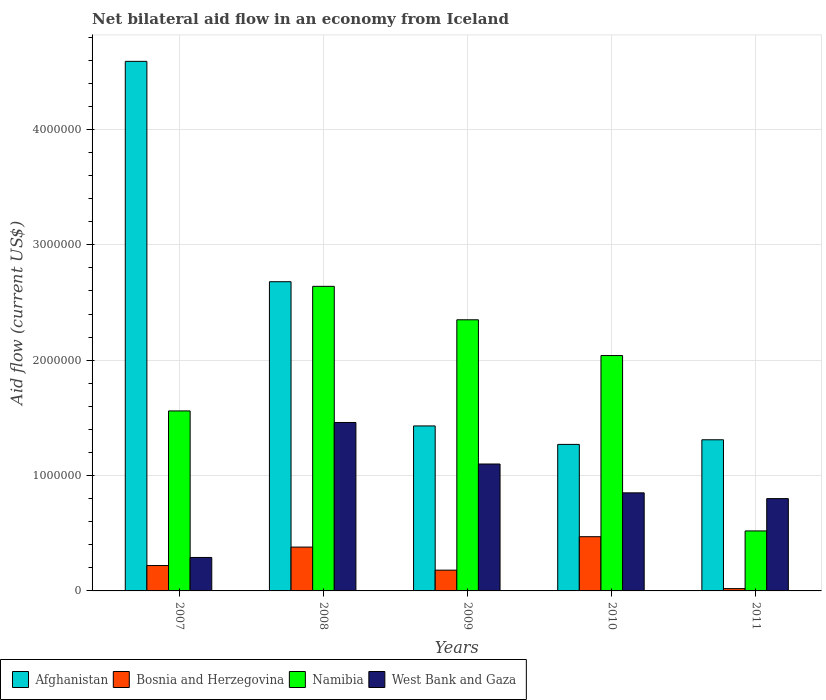Are the number of bars per tick equal to the number of legend labels?
Your answer should be very brief. Yes. What is the net bilateral aid flow in Namibia in 2010?
Provide a short and direct response. 2.04e+06. Across all years, what is the maximum net bilateral aid flow in Namibia?
Keep it short and to the point. 2.64e+06. In which year was the net bilateral aid flow in Namibia minimum?
Make the answer very short. 2011. What is the total net bilateral aid flow in Afghanistan in the graph?
Your answer should be very brief. 1.13e+07. What is the difference between the net bilateral aid flow in Afghanistan in 2007 and the net bilateral aid flow in Bosnia and Herzegovina in 2010?
Provide a succinct answer. 4.12e+06. What is the average net bilateral aid flow in Bosnia and Herzegovina per year?
Provide a short and direct response. 2.54e+05. In the year 2008, what is the difference between the net bilateral aid flow in West Bank and Gaza and net bilateral aid flow in Bosnia and Herzegovina?
Ensure brevity in your answer.  1.08e+06. In how many years, is the net bilateral aid flow in Bosnia and Herzegovina greater than 4600000 US$?
Offer a very short reply. 0. What is the ratio of the net bilateral aid flow in Namibia in 2007 to that in 2011?
Offer a very short reply. 3. What is the difference between the highest and the lowest net bilateral aid flow in Afghanistan?
Offer a terse response. 3.32e+06. Is the sum of the net bilateral aid flow in Bosnia and Herzegovina in 2008 and 2009 greater than the maximum net bilateral aid flow in Afghanistan across all years?
Make the answer very short. No. What does the 2nd bar from the left in 2010 represents?
Your response must be concise. Bosnia and Herzegovina. What does the 2nd bar from the right in 2008 represents?
Give a very brief answer. Namibia. Are all the bars in the graph horizontal?
Your answer should be compact. No. Are the values on the major ticks of Y-axis written in scientific E-notation?
Provide a short and direct response. No. Does the graph contain any zero values?
Give a very brief answer. No. Does the graph contain grids?
Ensure brevity in your answer.  Yes. How many legend labels are there?
Keep it short and to the point. 4. What is the title of the graph?
Provide a succinct answer. Net bilateral aid flow in an economy from Iceland. Does "Colombia" appear as one of the legend labels in the graph?
Offer a terse response. No. What is the label or title of the X-axis?
Keep it short and to the point. Years. What is the Aid flow (current US$) in Afghanistan in 2007?
Keep it short and to the point. 4.59e+06. What is the Aid flow (current US$) of Namibia in 2007?
Offer a terse response. 1.56e+06. What is the Aid flow (current US$) in Afghanistan in 2008?
Offer a very short reply. 2.68e+06. What is the Aid flow (current US$) of Bosnia and Herzegovina in 2008?
Offer a very short reply. 3.80e+05. What is the Aid flow (current US$) in Namibia in 2008?
Offer a very short reply. 2.64e+06. What is the Aid flow (current US$) of West Bank and Gaza in 2008?
Make the answer very short. 1.46e+06. What is the Aid flow (current US$) of Afghanistan in 2009?
Provide a short and direct response. 1.43e+06. What is the Aid flow (current US$) in Namibia in 2009?
Ensure brevity in your answer.  2.35e+06. What is the Aid flow (current US$) of West Bank and Gaza in 2009?
Your answer should be very brief. 1.10e+06. What is the Aid flow (current US$) in Afghanistan in 2010?
Provide a succinct answer. 1.27e+06. What is the Aid flow (current US$) of Bosnia and Herzegovina in 2010?
Your response must be concise. 4.70e+05. What is the Aid flow (current US$) of Namibia in 2010?
Your answer should be very brief. 2.04e+06. What is the Aid flow (current US$) in West Bank and Gaza in 2010?
Give a very brief answer. 8.50e+05. What is the Aid flow (current US$) in Afghanistan in 2011?
Offer a very short reply. 1.31e+06. What is the Aid flow (current US$) of Bosnia and Herzegovina in 2011?
Your answer should be compact. 2.00e+04. What is the Aid flow (current US$) of Namibia in 2011?
Make the answer very short. 5.20e+05. Across all years, what is the maximum Aid flow (current US$) in Afghanistan?
Your answer should be very brief. 4.59e+06. Across all years, what is the maximum Aid flow (current US$) in Namibia?
Make the answer very short. 2.64e+06. Across all years, what is the maximum Aid flow (current US$) in West Bank and Gaza?
Offer a very short reply. 1.46e+06. Across all years, what is the minimum Aid flow (current US$) of Afghanistan?
Give a very brief answer. 1.27e+06. Across all years, what is the minimum Aid flow (current US$) of Namibia?
Offer a very short reply. 5.20e+05. Across all years, what is the minimum Aid flow (current US$) in West Bank and Gaza?
Keep it short and to the point. 2.90e+05. What is the total Aid flow (current US$) in Afghanistan in the graph?
Give a very brief answer. 1.13e+07. What is the total Aid flow (current US$) of Bosnia and Herzegovina in the graph?
Ensure brevity in your answer.  1.27e+06. What is the total Aid flow (current US$) of Namibia in the graph?
Give a very brief answer. 9.11e+06. What is the total Aid flow (current US$) of West Bank and Gaza in the graph?
Offer a very short reply. 4.50e+06. What is the difference between the Aid flow (current US$) in Afghanistan in 2007 and that in 2008?
Offer a very short reply. 1.91e+06. What is the difference between the Aid flow (current US$) of Bosnia and Herzegovina in 2007 and that in 2008?
Your answer should be very brief. -1.60e+05. What is the difference between the Aid flow (current US$) of Namibia in 2007 and that in 2008?
Your answer should be compact. -1.08e+06. What is the difference between the Aid flow (current US$) in West Bank and Gaza in 2007 and that in 2008?
Your answer should be compact. -1.17e+06. What is the difference between the Aid flow (current US$) of Afghanistan in 2007 and that in 2009?
Give a very brief answer. 3.16e+06. What is the difference between the Aid flow (current US$) in Namibia in 2007 and that in 2009?
Ensure brevity in your answer.  -7.90e+05. What is the difference between the Aid flow (current US$) in West Bank and Gaza in 2007 and that in 2009?
Your answer should be compact. -8.10e+05. What is the difference between the Aid flow (current US$) of Afghanistan in 2007 and that in 2010?
Your response must be concise. 3.32e+06. What is the difference between the Aid flow (current US$) in Bosnia and Herzegovina in 2007 and that in 2010?
Provide a succinct answer. -2.50e+05. What is the difference between the Aid flow (current US$) in Namibia in 2007 and that in 2010?
Offer a very short reply. -4.80e+05. What is the difference between the Aid flow (current US$) of West Bank and Gaza in 2007 and that in 2010?
Offer a very short reply. -5.60e+05. What is the difference between the Aid flow (current US$) of Afghanistan in 2007 and that in 2011?
Your answer should be compact. 3.28e+06. What is the difference between the Aid flow (current US$) of Namibia in 2007 and that in 2011?
Provide a short and direct response. 1.04e+06. What is the difference between the Aid flow (current US$) of West Bank and Gaza in 2007 and that in 2011?
Keep it short and to the point. -5.10e+05. What is the difference between the Aid flow (current US$) in Afghanistan in 2008 and that in 2009?
Your answer should be very brief. 1.25e+06. What is the difference between the Aid flow (current US$) of Namibia in 2008 and that in 2009?
Make the answer very short. 2.90e+05. What is the difference between the Aid flow (current US$) of West Bank and Gaza in 2008 and that in 2009?
Your answer should be compact. 3.60e+05. What is the difference between the Aid flow (current US$) in Afghanistan in 2008 and that in 2010?
Your response must be concise. 1.41e+06. What is the difference between the Aid flow (current US$) of Bosnia and Herzegovina in 2008 and that in 2010?
Your answer should be very brief. -9.00e+04. What is the difference between the Aid flow (current US$) in Namibia in 2008 and that in 2010?
Provide a succinct answer. 6.00e+05. What is the difference between the Aid flow (current US$) in Afghanistan in 2008 and that in 2011?
Offer a very short reply. 1.37e+06. What is the difference between the Aid flow (current US$) of Bosnia and Herzegovina in 2008 and that in 2011?
Your response must be concise. 3.60e+05. What is the difference between the Aid flow (current US$) of Namibia in 2008 and that in 2011?
Keep it short and to the point. 2.12e+06. What is the difference between the Aid flow (current US$) of West Bank and Gaza in 2008 and that in 2011?
Your answer should be very brief. 6.60e+05. What is the difference between the Aid flow (current US$) in Afghanistan in 2009 and that in 2010?
Offer a very short reply. 1.60e+05. What is the difference between the Aid flow (current US$) in Namibia in 2009 and that in 2010?
Make the answer very short. 3.10e+05. What is the difference between the Aid flow (current US$) in Namibia in 2009 and that in 2011?
Your response must be concise. 1.83e+06. What is the difference between the Aid flow (current US$) of Afghanistan in 2010 and that in 2011?
Keep it short and to the point. -4.00e+04. What is the difference between the Aid flow (current US$) of Namibia in 2010 and that in 2011?
Your response must be concise. 1.52e+06. What is the difference between the Aid flow (current US$) of West Bank and Gaza in 2010 and that in 2011?
Offer a very short reply. 5.00e+04. What is the difference between the Aid flow (current US$) in Afghanistan in 2007 and the Aid flow (current US$) in Bosnia and Herzegovina in 2008?
Provide a short and direct response. 4.21e+06. What is the difference between the Aid flow (current US$) in Afghanistan in 2007 and the Aid flow (current US$) in Namibia in 2008?
Ensure brevity in your answer.  1.95e+06. What is the difference between the Aid flow (current US$) in Afghanistan in 2007 and the Aid flow (current US$) in West Bank and Gaza in 2008?
Provide a succinct answer. 3.13e+06. What is the difference between the Aid flow (current US$) of Bosnia and Herzegovina in 2007 and the Aid flow (current US$) of Namibia in 2008?
Your response must be concise. -2.42e+06. What is the difference between the Aid flow (current US$) of Bosnia and Herzegovina in 2007 and the Aid flow (current US$) of West Bank and Gaza in 2008?
Give a very brief answer. -1.24e+06. What is the difference between the Aid flow (current US$) in Afghanistan in 2007 and the Aid flow (current US$) in Bosnia and Herzegovina in 2009?
Your answer should be compact. 4.41e+06. What is the difference between the Aid flow (current US$) of Afghanistan in 2007 and the Aid flow (current US$) of Namibia in 2009?
Provide a short and direct response. 2.24e+06. What is the difference between the Aid flow (current US$) in Afghanistan in 2007 and the Aid flow (current US$) in West Bank and Gaza in 2009?
Provide a short and direct response. 3.49e+06. What is the difference between the Aid flow (current US$) in Bosnia and Herzegovina in 2007 and the Aid flow (current US$) in Namibia in 2009?
Your answer should be compact. -2.13e+06. What is the difference between the Aid flow (current US$) of Bosnia and Herzegovina in 2007 and the Aid flow (current US$) of West Bank and Gaza in 2009?
Keep it short and to the point. -8.80e+05. What is the difference between the Aid flow (current US$) in Namibia in 2007 and the Aid flow (current US$) in West Bank and Gaza in 2009?
Keep it short and to the point. 4.60e+05. What is the difference between the Aid flow (current US$) of Afghanistan in 2007 and the Aid flow (current US$) of Bosnia and Herzegovina in 2010?
Ensure brevity in your answer.  4.12e+06. What is the difference between the Aid flow (current US$) of Afghanistan in 2007 and the Aid flow (current US$) of Namibia in 2010?
Offer a very short reply. 2.55e+06. What is the difference between the Aid flow (current US$) of Afghanistan in 2007 and the Aid flow (current US$) of West Bank and Gaza in 2010?
Provide a succinct answer. 3.74e+06. What is the difference between the Aid flow (current US$) in Bosnia and Herzegovina in 2007 and the Aid flow (current US$) in Namibia in 2010?
Give a very brief answer. -1.82e+06. What is the difference between the Aid flow (current US$) of Bosnia and Herzegovina in 2007 and the Aid flow (current US$) of West Bank and Gaza in 2010?
Offer a very short reply. -6.30e+05. What is the difference between the Aid flow (current US$) of Namibia in 2007 and the Aid flow (current US$) of West Bank and Gaza in 2010?
Offer a terse response. 7.10e+05. What is the difference between the Aid flow (current US$) of Afghanistan in 2007 and the Aid flow (current US$) of Bosnia and Herzegovina in 2011?
Provide a short and direct response. 4.57e+06. What is the difference between the Aid flow (current US$) in Afghanistan in 2007 and the Aid flow (current US$) in Namibia in 2011?
Ensure brevity in your answer.  4.07e+06. What is the difference between the Aid flow (current US$) in Afghanistan in 2007 and the Aid flow (current US$) in West Bank and Gaza in 2011?
Your answer should be compact. 3.79e+06. What is the difference between the Aid flow (current US$) in Bosnia and Herzegovina in 2007 and the Aid flow (current US$) in Namibia in 2011?
Your response must be concise. -3.00e+05. What is the difference between the Aid flow (current US$) of Bosnia and Herzegovina in 2007 and the Aid flow (current US$) of West Bank and Gaza in 2011?
Your response must be concise. -5.80e+05. What is the difference between the Aid flow (current US$) in Namibia in 2007 and the Aid flow (current US$) in West Bank and Gaza in 2011?
Your answer should be very brief. 7.60e+05. What is the difference between the Aid flow (current US$) in Afghanistan in 2008 and the Aid flow (current US$) in Bosnia and Herzegovina in 2009?
Your response must be concise. 2.50e+06. What is the difference between the Aid flow (current US$) in Afghanistan in 2008 and the Aid flow (current US$) in Namibia in 2009?
Offer a terse response. 3.30e+05. What is the difference between the Aid flow (current US$) in Afghanistan in 2008 and the Aid flow (current US$) in West Bank and Gaza in 2009?
Give a very brief answer. 1.58e+06. What is the difference between the Aid flow (current US$) of Bosnia and Herzegovina in 2008 and the Aid flow (current US$) of Namibia in 2009?
Offer a terse response. -1.97e+06. What is the difference between the Aid flow (current US$) of Bosnia and Herzegovina in 2008 and the Aid flow (current US$) of West Bank and Gaza in 2009?
Make the answer very short. -7.20e+05. What is the difference between the Aid flow (current US$) of Namibia in 2008 and the Aid flow (current US$) of West Bank and Gaza in 2009?
Make the answer very short. 1.54e+06. What is the difference between the Aid flow (current US$) of Afghanistan in 2008 and the Aid flow (current US$) of Bosnia and Herzegovina in 2010?
Provide a short and direct response. 2.21e+06. What is the difference between the Aid flow (current US$) in Afghanistan in 2008 and the Aid flow (current US$) in Namibia in 2010?
Your response must be concise. 6.40e+05. What is the difference between the Aid flow (current US$) in Afghanistan in 2008 and the Aid flow (current US$) in West Bank and Gaza in 2010?
Your answer should be compact. 1.83e+06. What is the difference between the Aid flow (current US$) in Bosnia and Herzegovina in 2008 and the Aid flow (current US$) in Namibia in 2010?
Your answer should be compact. -1.66e+06. What is the difference between the Aid flow (current US$) in Bosnia and Herzegovina in 2008 and the Aid flow (current US$) in West Bank and Gaza in 2010?
Your answer should be compact. -4.70e+05. What is the difference between the Aid flow (current US$) in Namibia in 2008 and the Aid flow (current US$) in West Bank and Gaza in 2010?
Your response must be concise. 1.79e+06. What is the difference between the Aid flow (current US$) of Afghanistan in 2008 and the Aid flow (current US$) of Bosnia and Herzegovina in 2011?
Provide a short and direct response. 2.66e+06. What is the difference between the Aid flow (current US$) in Afghanistan in 2008 and the Aid flow (current US$) in Namibia in 2011?
Provide a succinct answer. 2.16e+06. What is the difference between the Aid flow (current US$) of Afghanistan in 2008 and the Aid flow (current US$) of West Bank and Gaza in 2011?
Keep it short and to the point. 1.88e+06. What is the difference between the Aid flow (current US$) in Bosnia and Herzegovina in 2008 and the Aid flow (current US$) in West Bank and Gaza in 2011?
Your answer should be very brief. -4.20e+05. What is the difference between the Aid flow (current US$) of Namibia in 2008 and the Aid flow (current US$) of West Bank and Gaza in 2011?
Your answer should be compact. 1.84e+06. What is the difference between the Aid flow (current US$) in Afghanistan in 2009 and the Aid flow (current US$) in Bosnia and Herzegovina in 2010?
Offer a very short reply. 9.60e+05. What is the difference between the Aid flow (current US$) in Afghanistan in 2009 and the Aid flow (current US$) in Namibia in 2010?
Provide a succinct answer. -6.10e+05. What is the difference between the Aid flow (current US$) in Afghanistan in 2009 and the Aid flow (current US$) in West Bank and Gaza in 2010?
Make the answer very short. 5.80e+05. What is the difference between the Aid flow (current US$) of Bosnia and Herzegovina in 2009 and the Aid flow (current US$) of Namibia in 2010?
Your response must be concise. -1.86e+06. What is the difference between the Aid flow (current US$) of Bosnia and Herzegovina in 2009 and the Aid flow (current US$) of West Bank and Gaza in 2010?
Your response must be concise. -6.70e+05. What is the difference between the Aid flow (current US$) of Namibia in 2009 and the Aid flow (current US$) of West Bank and Gaza in 2010?
Your answer should be very brief. 1.50e+06. What is the difference between the Aid flow (current US$) of Afghanistan in 2009 and the Aid flow (current US$) of Bosnia and Herzegovina in 2011?
Give a very brief answer. 1.41e+06. What is the difference between the Aid flow (current US$) of Afghanistan in 2009 and the Aid flow (current US$) of Namibia in 2011?
Your answer should be very brief. 9.10e+05. What is the difference between the Aid flow (current US$) of Afghanistan in 2009 and the Aid flow (current US$) of West Bank and Gaza in 2011?
Ensure brevity in your answer.  6.30e+05. What is the difference between the Aid flow (current US$) of Bosnia and Herzegovina in 2009 and the Aid flow (current US$) of West Bank and Gaza in 2011?
Give a very brief answer. -6.20e+05. What is the difference between the Aid flow (current US$) of Namibia in 2009 and the Aid flow (current US$) of West Bank and Gaza in 2011?
Offer a very short reply. 1.55e+06. What is the difference between the Aid flow (current US$) of Afghanistan in 2010 and the Aid flow (current US$) of Bosnia and Herzegovina in 2011?
Offer a very short reply. 1.25e+06. What is the difference between the Aid flow (current US$) in Afghanistan in 2010 and the Aid flow (current US$) in Namibia in 2011?
Offer a very short reply. 7.50e+05. What is the difference between the Aid flow (current US$) in Bosnia and Herzegovina in 2010 and the Aid flow (current US$) in Namibia in 2011?
Offer a terse response. -5.00e+04. What is the difference between the Aid flow (current US$) of Bosnia and Herzegovina in 2010 and the Aid flow (current US$) of West Bank and Gaza in 2011?
Provide a succinct answer. -3.30e+05. What is the difference between the Aid flow (current US$) in Namibia in 2010 and the Aid flow (current US$) in West Bank and Gaza in 2011?
Provide a short and direct response. 1.24e+06. What is the average Aid flow (current US$) of Afghanistan per year?
Your answer should be compact. 2.26e+06. What is the average Aid flow (current US$) in Bosnia and Herzegovina per year?
Give a very brief answer. 2.54e+05. What is the average Aid flow (current US$) in Namibia per year?
Provide a short and direct response. 1.82e+06. What is the average Aid flow (current US$) of West Bank and Gaza per year?
Make the answer very short. 9.00e+05. In the year 2007, what is the difference between the Aid flow (current US$) in Afghanistan and Aid flow (current US$) in Bosnia and Herzegovina?
Make the answer very short. 4.37e+06. In the year 2007, what is the difference between the Aid flow (current US$) of Afghanistan and Aid flow (current US$) of Namibia?
Your answer should be compact. 3.03e+06. In the year 2007, what is the difference between the Aid flow (current US$) in Afghanistan and Aid flow (current US$) in West Bank and Gaza?
Make the answer very short. 4.30e+06. In the year 2007, what is the difference between the Aid flow (current US$) of Bosnia and Herzegovina and Aid flow (current US$) of Namibia?
Make the answer very short. -1.34e+06. In the year 2007, what is the difference between the Aid flow (current US$) in Bosnia and Herzegovina and Aid flow (current US$) in West Bank and Gaza?
Give a very brief answer. -7.00e+04. In the year 2007, what is the difference between the Aid flow (current US$) in Namibia and Aid flow (current US$) in West Bank and Gaza?
Ensure brevity in your answer.  1.27e+06. In the year 2008, what is the difference between the Aid flow (current US$) in Afghanistan and Aid flow (current US$) in Bosnia and Herzegovina?
Make the answer very short. 2.30e+06. In the year 2008, what is the difference between the Aid flow (current US$) of Afghanistan and Aid flow (current US$) of West Bank and Gaza?
Offer a very short reply. 1.22e+06. In the year 2008, what is the difference between the Aid flow (current US$) in Bosnia and Herzegovina and Aid flow (current US$) in Namibia?
Your response must be concise. -2.26e+06. In the year 2008, what is the difference between the Aid flow (current US$) in Bosnia and Herzegovina and Aid flow (current US$) in West Bank and Gaza?
Provide a short and direct response. -1.08e+06. In the year 2008, what is the difference between the Aid flow (current US$) of Namibia and Aid flow (current US$) of West Bank and Gaza?
Offer a terse response. 1.18e+06. In the year 2009, what is the difference between the Aid flow (current US$) of Afghanistan and Aid flow (current US$) of Bosnia and Herzegovina?
Your answer should be very brief. 1.25e+06. In the year 2009, what is the difference between the Aid flow (current US$) in Afghanistan and Aid flow (current US$) in Namibia?
Make the answer very short. -9.20e+05. In the year 2009, what is the difference between the Aid flow (current US$) of Afghanistan and Aid flow (current US$) of West Bank and Gaza?
Make the answer very short. 3.30e+05. In the year 2009, what is the difference between the Aid flow (current US$) of Bosnia and Herzegovina and Aid flow (current US$) of Namibia?
Your answer should be compact. -2.17e+06. In the year 2009, what is the difference between the Aid flow (current US$) of Bosnia and Herzegovina and Aid flow (current US$) of West Bank and Gaza?
Your answer should be compact. -9.20e+05. In the year 2009, what is the difference between the Aid flow (current US$) of Namibia and Aid flow (current US$) of West Bank and Gaza?
Your response must be concise. 1.25e+06. In the year 2010, what is the difference between the Aid flow (current US$) of Afghanistan and Aid flow (current US$) of Bosnia and Herzegovina?
Provide a succinct answer. 8.00e+05. In the year 2010, what is the difference between the Aid flow (current US$) in Afghanistan and Aid flow (current US$) in Namibia?
Give a very brief answer. -7.70e+05. In the year 2010, what is the difference between the Aid flow (current US$) in Bosnia and Herzegovina and Aid flow (current US$) in Namibia?
Offer a very short reply. -1.57e+06. In the year 2010, what is the difference between the Aid flow (current US$) of Bosnia and Herzegovina and Aid flow (current US$) of West Bank and Gaza?
Give a very brief answer. -3.80e+05. In the year 2010, what is the difference between the Aid flow (current US$) of Namibia and Aid flow (current US$) of West Bank and Gaza?
Provide a succinct answer. 1.19e+06. In the year 2011, what is the difference between the Aid flow (current US$) of Afghanistan and Aid flow (current US$) of Bosnia and Herzegovina?
Your response must be concise. 1.29e+06. In the year 2011, what is the difference between the Aid flow (current US$) of Afghanistan and Aid flow (current US$) of Namibia?
Offer a terse response. 7.90e+05. In the year 2011, what is the difference between the Aid flow (current US$) of Afghanistan and Aid flow (current US$) of West Bank and Gaza?
Provide a short and direct response. 5.10e+05. In the year 2011, what is the difference between the Aid flow (current US$) of Bosnia and Herzegovina and Aid flow (current US$) of Namibia?
Your answer should be very brief. -5.00e+05. In the year 2011, what is the difference between the Aid flow (current US$) of Bosnia and Herzegovina and Aid flow (current US$) of West Bank and Gaza?
Your answer should be very brief. -7.80e+05. In the year 2011, what is the difference between the Aid flow (current US$) of Namibia and Aid flow (current US$) of West Bank and Gaza?
Offer a terse response. -2.80e+05. What is the ratio of the Aid flow (current US$) in Afghanistan in 2007 to that in 2008?
Make the answer very short. 1.71. What is the ratio of the Aid flow (current US$) in Bosnia and Herzegovina in 2007 to that in 2008?
Offer a very short reply. 0.58. What is the ratio of the Aid flow (current US$) in Namibia in 2007 to that in 2008?
Provide a succinct answer. 0.59. What is the ratio of the Aid flow (current US$) in West Bank and Gaza in 2007 to that in 2008?
Provide a short and direct response. 0.2. What is the ratio of the Aid flow (current US$) in Afghanistan in 2007 to that in 2009?
Offer a terse response. 3.21. What is the ratio of the Aid flow (current US$) of Bosnia and Herzegovina in 2007 to that in 2009?
Make the answer very short. 1.22. What is the ratio of the Aid flow (current US$) of Namibia in 2007 to that in 2009?
Offer a very short reply. 0.66. What is the ratio of the Aid flow (current US$) of West Bank and Gaza in 2007 to that in 2009?
Ensure brevity in your answer.  0.26. What is the ratio of the Aid flow (current US$) in Afghanistan in 2007 to that in 2010?
Keep it short and to the point. 3.61. What is the ratio of the Aid flow (current US$) of Bosnia and Herzegovina in 2007 to that in 2010?
Make the answer very short. 0.47. What is the ratio of the Aid flow (current US$) in Namibia in 2007 to that in 2010?
Ensure brevity in your answer.  0.76. What is the ratio of the Aid flow (current US$) of West Bank and Gaza in 2007 to that in 2010?
Offer a very short reply. 0.34. What is the ratio of the Aid flow (current US$) of Afghanistan in 2007 to that in 2011?
Make the answer very short. 3.5. What is the ratio of the Aid flow (current US$) in Namibia in 2007 to that in 2011?
Your response must be concise. 3. What is the ratio of the Aid flow (current US$) of West Bank and Gaza in 2007 to that in 2011?
Provide a short and direct response. 0.36. What is the ratio of the Aid flow (current US$) of Afghanistan in 2008 to that in 2009?
Keep it short and to the point. 1.87. What is the ratio of the Aid flow (current US$) of Bosnia and Herzegovina in 2008 to that in 2009?
Ensure brevity in your answer.  2.11. What is the ratio of the Aid flow (current US$) in Namibia in 2008 to that in 2009?
Provide a short and direct response. 1.12. What is the ratio of the Aid flow (current US$) in West Bank and Gaza in 2008 to that in 2009?
Your answer should be compact. 1.33. What is the ratio of the Aid flow (current US$) of Afghanistan in 2008 to that in 2010?
Offer a terse response. 2.11. What is the ratio of the Aid flow (current US$) in Bosnia and Herzegovina in 2008 to that in 2010?
Ensure brevity in your answer.  0.81. What is the ratio of the Aid flow (current US$) in Namibia in 2008 to that in 2010?
Your response must be concise. 1.29. What is the ratio of the Aid flow (current US$) in West Bank and Gaza in 2008 to that in 2010?
Your answer should be compact. 1.72. What is the ratio of the Aid flow (current US$) in Afghanistan in 2008 to that in 2011?
Give a very brief answer. 2.05. What is the ratio of the Aid flow (current US$) in Bosnia and Herzegovina in 2008 to that in 2011?
Give a very brief answer. 19. What is the ratio of the Aid flow (current US$) in Namibia in 2008 to that in 2011?
Provide a short and direct response. 5.08. What is the ratio of the Aid flow (current US$) in West Bank and Gaza in 2008 to that in 2011?
Give a very brief answer. 1.82. What is the ratio of the Aid flow (current US$) in Afghanistan in 2009 to that in 2010?
Keep it short and to the point. 1.13. What is the ratio of the Aid flow (current US$) of Bosnia and Herzegovina in 2009 to that in 2010?
Your answer should be very brief. 0.38. What is the ratio of the Aid flow (current US$) in Namibia in 2009 to that in 2010?
Keep it short and to the point. 1.15. What is the ratio of the Aid flow (current US$) in West Bank and Gaza in 2009 to that in 2010?
Offer a terse response. 1.29. What is the ratio of the Aid flow (current US$) in Afghanistan in 2009 to that in 2011?
Your response must be concise. 1.09. What is the ratio of the Aid flow (current US$) in Bosnia and Herzegovina in 2009 to that in 2011?
Your answer should be very brief. 9. What is the ratio of the Aid flow (current US$) of Namibia in 2009 to that in 2011?
Offer a terse response. 4.52. What is the ratio of the Aid flow (current US$) in West Bank and Gaza in 2009 to that in 2011?
Offer a very short reply. 1.38. What is the ratio of the Aid flow (current US$) in Afghanistan in 2010 to that in 2011?
Make the answer very short. 0.97. What is the ratio of the Aid flow (current US$) in Namibia in 2010 to that in 2011?
Give a very brief answer. 3.92. What is the ratio of the Aid flow (current US$) in West Bank and Gaza in 2010 to that in 2011?
Offer a terse response. 1.06. What is the difference between the highest and the second highest Aid flow (current US$) of Afghanistan?
Give a very brief answer. 1.91e+06. What is the difference between the highest and the second highest Aid flow (current US$) in Bosnia and Herzegovina?
Your answer should be very brief. 9.00e+04. What is the difference between the highest and the second highest Aid flow (current US$) of West Bank and Gaza?
Provide a succinct answer. 3.60e+05. What is the difference between the highest and the lowest Aid flow (current US$) of Afghanistan?
Ensure brevity in your answer.  3.32e+06. What is the difference between the highest and the lowest Aid flow (current US$) of Namibia?
Provide a succinct answer. 2.12e+06. What is the difference between the highest and the lowest Aid flow (current US$) of West Bank and Gaza?
Give a very brief answer. 1.17e+06. 